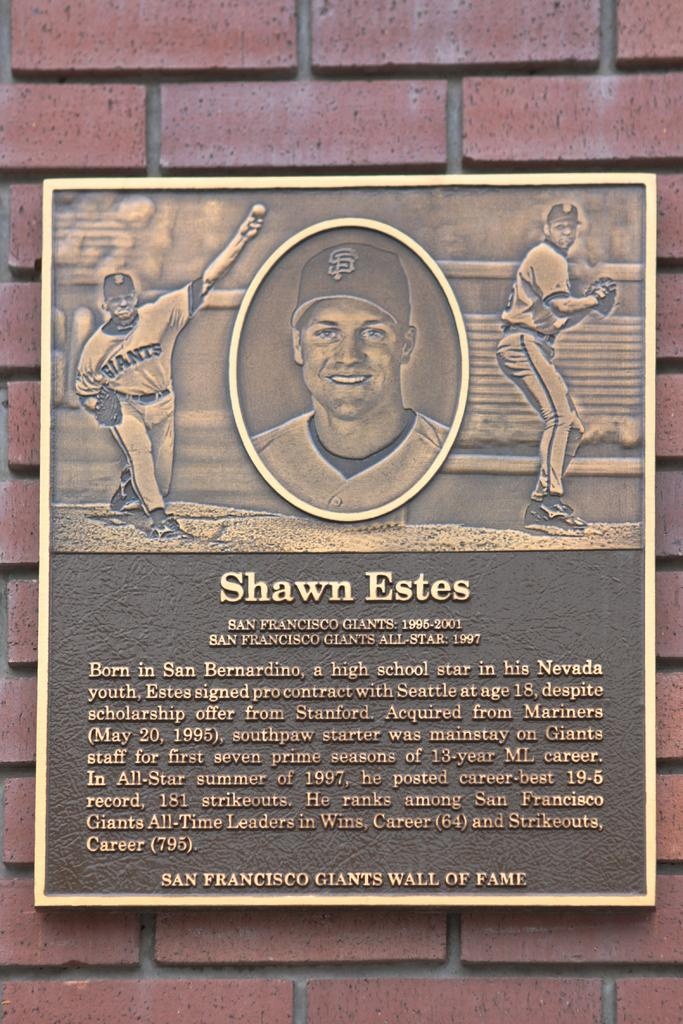Provide a one-sentence caption for the provided image. A shawn Estes plaque on the san francisco giants wall of fame. It has A bio of Shawn Estes and a photo of him. 